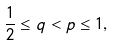Convert formula to latex. <formula><loc_0><loc_0><loc_500><loc_500>\frac { 1 } { 2 } \leq q < p \leq 1 ,</formula> 